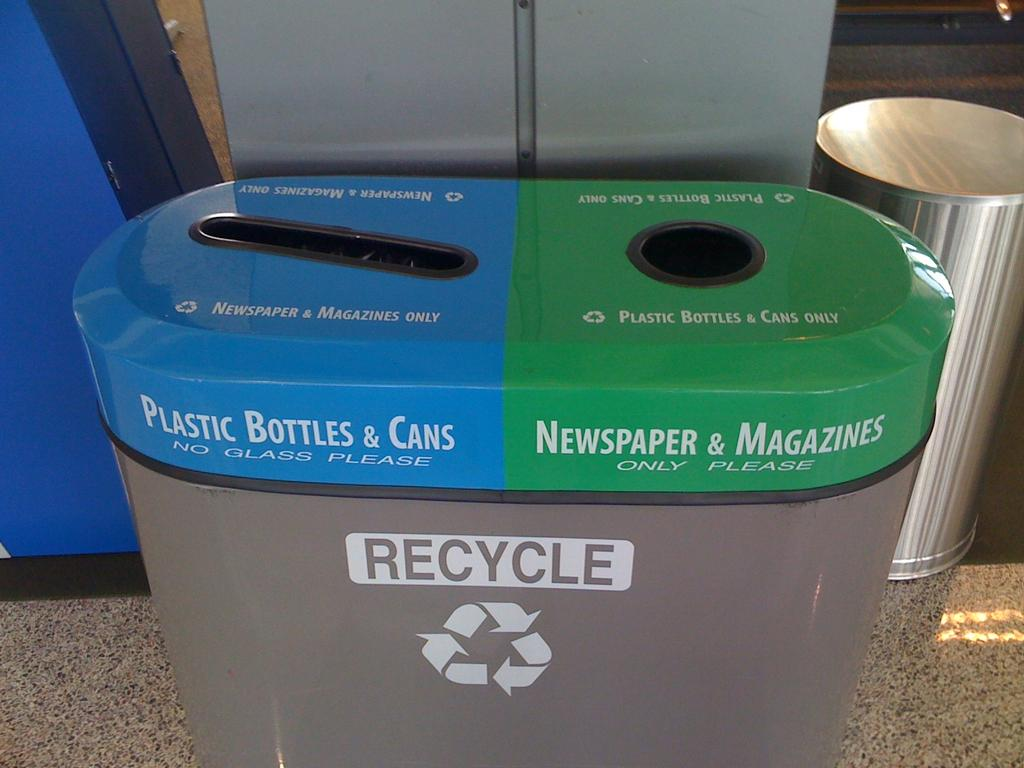<image>
Relay a brief, clear account of the picture shown. A recycling bin is shown, with the blue side for Plastic Bottles & Cans and the green side for Newspapers & Magazines. 